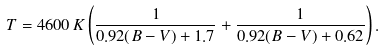Convert formula to latex. <formula><loc_0><loc_0><loc_500><loc_500>T = 4 6 0 0 \, K \left ( { \frac { 1 } { 0 . 9 2 ( B - V ) + 1 . 7 } } + { \frac { 1 } { 0 . 9 2 ( B - V ) + 0 . 6 2 } } \right ) .</formula> 